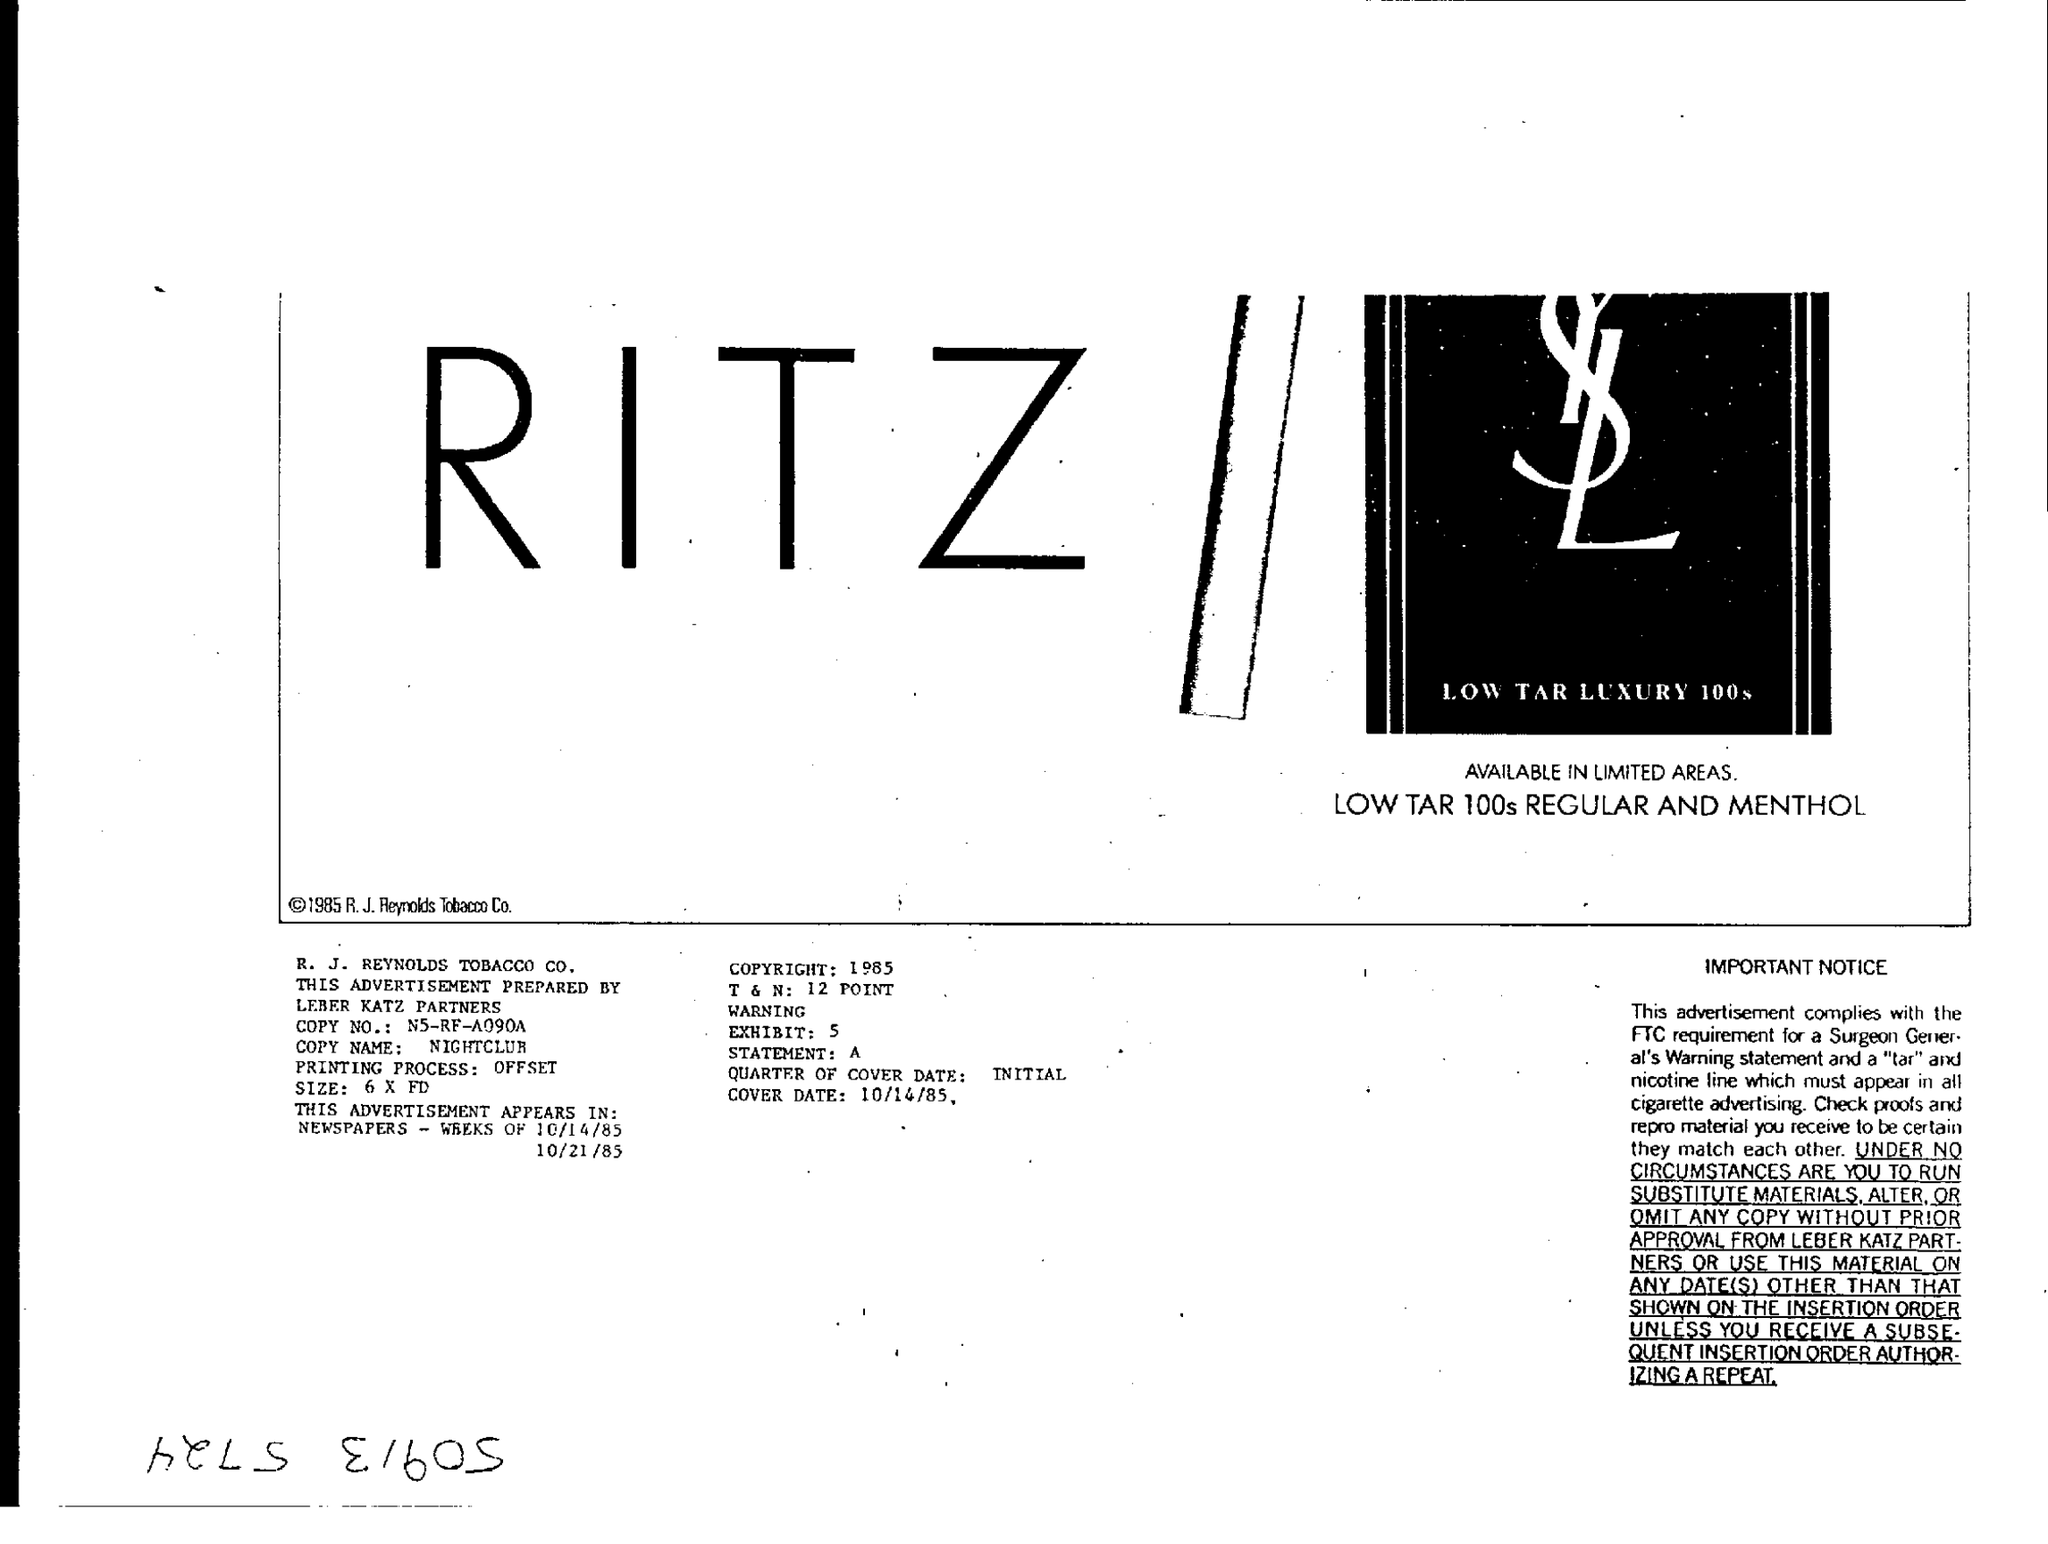What is written in big letters?
Give a very brief answer. RITZ. 